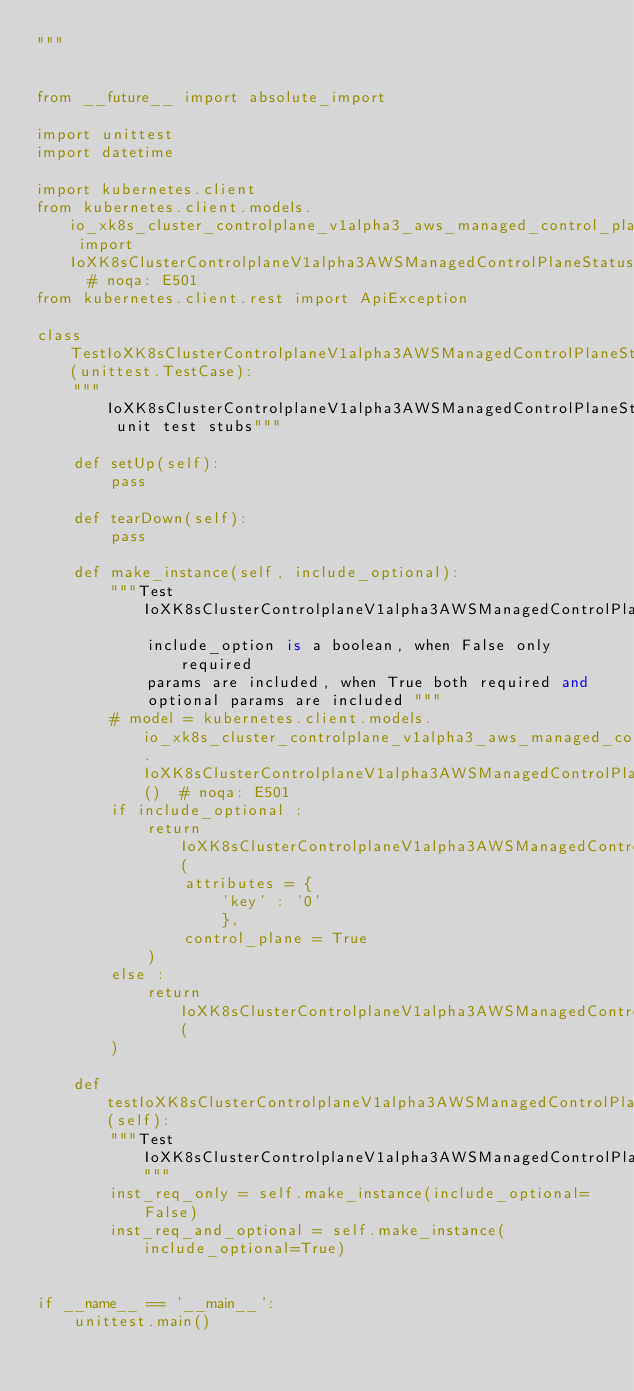<code> <loc_0><loc_0><loc_500><loc_500><_Python_>"""


from __future__ import absolute_import

import unittest
import datetime

import kubernetes.client
from kubernetes.client.models.io_xk8s_cluster_controlplane_v1alpha3_aws_managed_control_plane_status_failure_domains import IoXK8sClusterControlplaneV1alpha3AWSManagedControlPlaneStatusFailureDomains  # noqa: E501
from kubernetes.client.rest import ApiException

class TestIoXK8sClusterControlplaneV1alpha3AWSManagedControlPlaneStatusFailureDomains(unittest.TestCase):
    """IoXK8sClusterControlplaneV1alpha3AWSManagedControlPlaneStatusFailureDomains unit test stubs"""

    def setUp(self):
        pass

    def tearDown(self):
        pass

    def make_instance(self, include_optional):
        """Test IoXK8sClusterControlplaneV1alpha3AWSManagedControlPlaneStatusFailureDomains
            include_option is a boolean, when False only required
            params are included, when True both required and
            optional params are included """
        # model = kubernetes.client.models.io_xk8s_cluster_controlplane_v1alpha3_aws_managed_control_plane_status_failure_domains.IoXK8sClusterControlplaneV1alpha3AWSManagedControlPlaneStatusFailureDomains()  # noqa: E501
        if include_optional :
            return IoXK8sClusterControlplaneV1alpha3AWSManagedControlPlaneStatusFailureDomains(
                attributes = {
                    'key' : '0'
                    }, 
                control_plane = True
            )
        else :
            return IoXK8sClusterControlplaneV1alpha3AWSManagedControlPlaneStatusFailureDomains(
        )

    def testIoXK8sClusterControlplaneV1alpha3AWSManagedControlPlaneStatusFailureDomains(self):
        """Test IoXK8sClusterControlplaneV1alpha3AWSManagedControlPlaneStatusFailureDomains"""
        inst_req_only = self.make_instance(include_optional=False)
        inst_req_and_optional = self.make_instance(include_optional=True)


if __name__ == '__main__':
    unittest.main()
</code> 